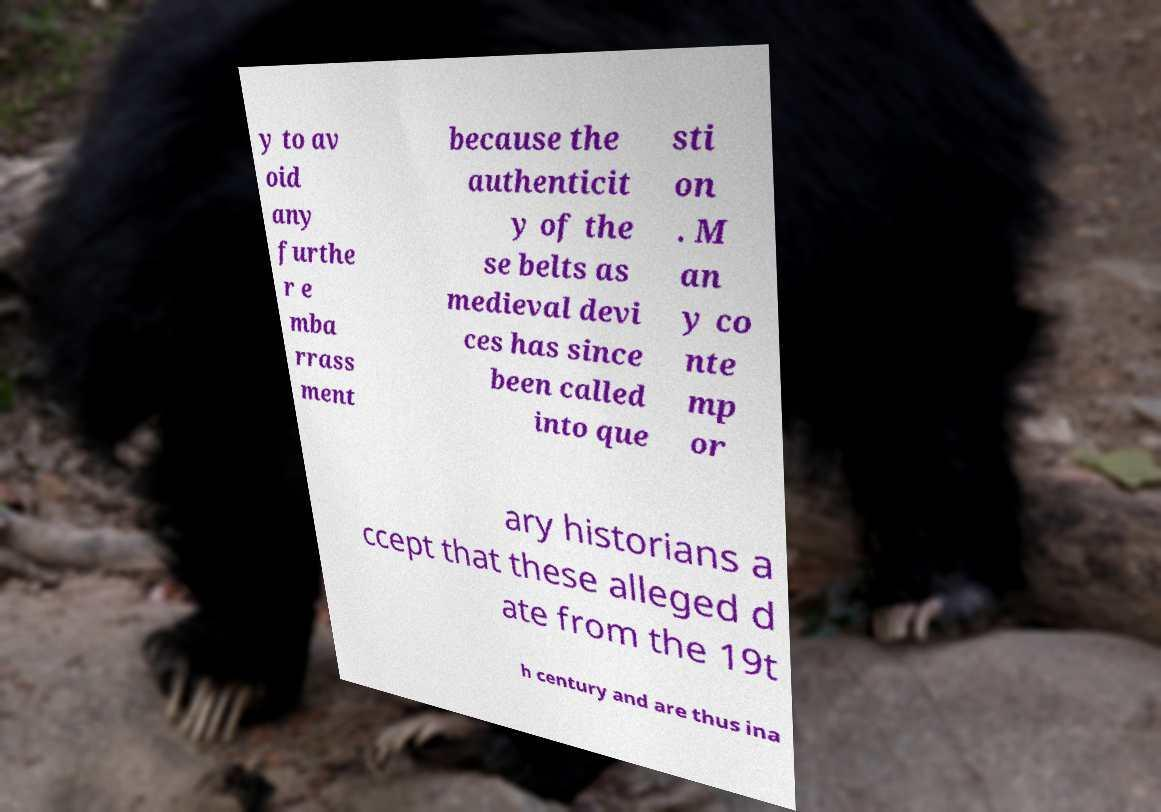Please identify and transcribe the text found in this image. y to av oid any furthe r e mba rrass ment because the authenticit y of the se belts as medieval devi ces has since been called into que sti on . M an y co nte mp or ary historians a ccept that these alleged d ate from the 19t h century and are thus ina 